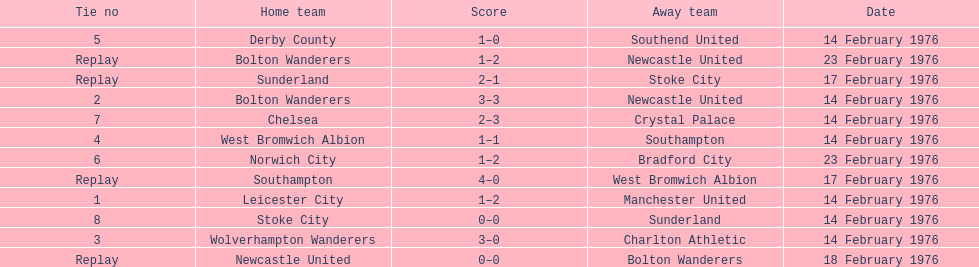How many games played by sunderland are listed here? 2. 